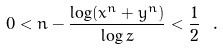Convert formula to latex. <formula><loc_0><loc_0><loc_500><loc_500>0 < n - \frac { \log ( x ^ { n } + y ^ { n } ) } { \log z } < \frac { 1 } { 2 } \ .</formula> 